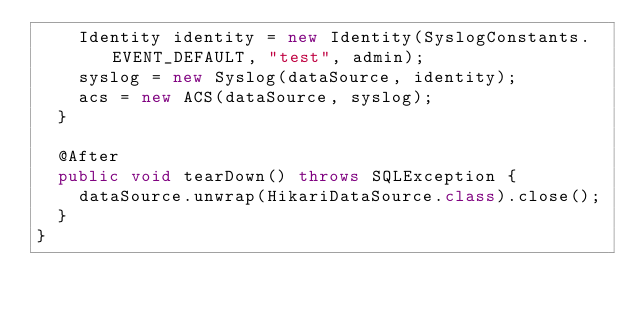Convert code to text. <code><loc_0><loc_0><loc_500><loc_500><_Java_>    Identity identity = new Identity(SyslogConstants.EVENT_DEFAULT, "test", admin);
    syslog = new Syslog(dataSource, identity);
    acs = new ACS(dataSource, syslog);
  }

  @After
  public void tearDown() throws SQLException {
    dataSource.unwrap(HikariDataSource.class).close();
  }
}
</code> 